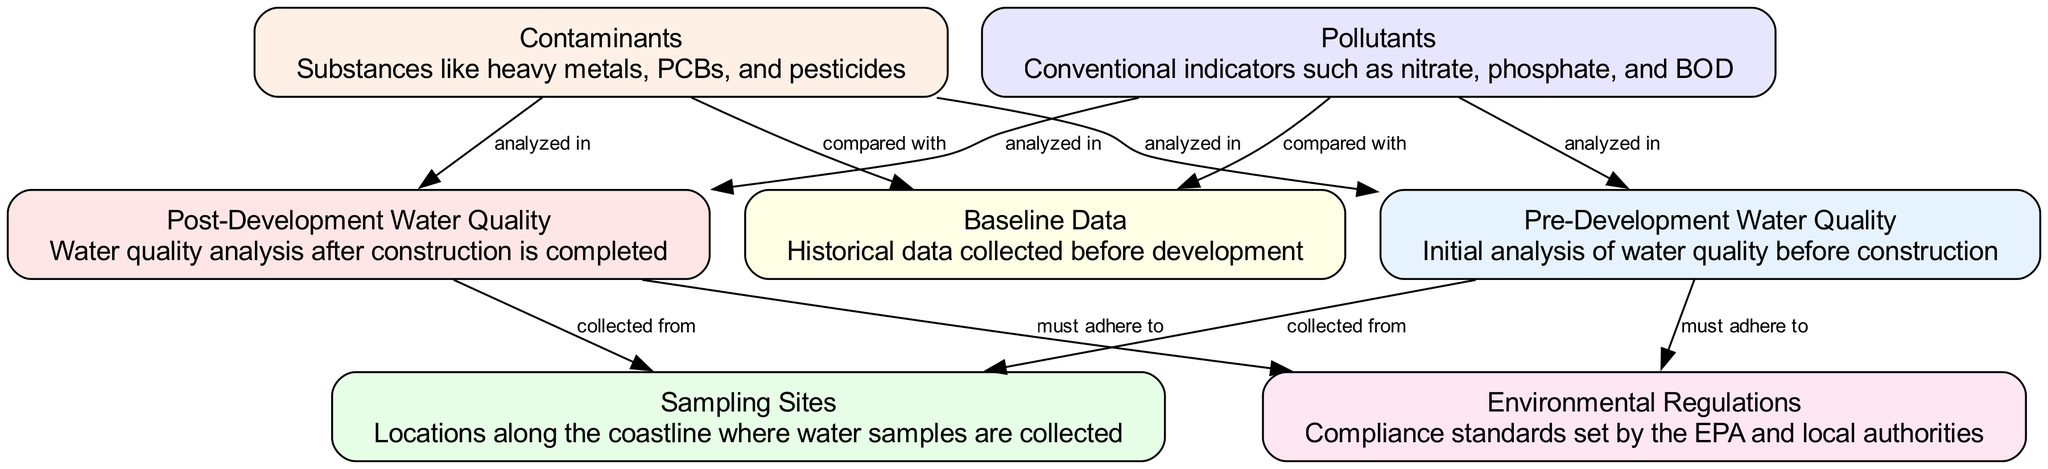What is the first node in the diagram? The first node listed is "Pre-Development Water Quality," as it is the first element in the nodes list provided.
Answer: Pre-Development Water Quality How many sampling sites are indicated in the diagram? The diagram does not specify the number of sampling sites, but it includes a node labeled "Sampling Sites." Since the data does not specify a quantity, the answer cannot be determined from the diagram.
Answer: Not specified What is compared with contaminants in the diagram? The diagram explicitly states that contaminants are compared with baseline data, as indicated by the edge labeled "compared with".
Answer: Baseline Data Which environmental standards must both water analyses adhere to? Both the "Pre-Development Water Quality" and "Post-Development Water Quality" nodes indicate that they must adhere to "Environmental Regulations," so the connection confirms compliance requirements from this perspective.
Answer: Environmental Regulations What types of substances are classified as contaminants? The node labeled "Contaminants" describes them as heavy metals, PCBs, and pesticides, providing clarity on what is included in this category.
Answer: Heavy metals, PCBs, and pesticides What is the relationship between water quality pre-development and analysis? Water quality pre-development is analyzed in the context of both contaminants and pollutants, as shown by the edges connecting these nodes back to "Pre-Development Water Quality."
Answer: Analyzed in Which node represents the analysis done after construction? The node labeled "Post-Development Water Quality" represents the analysis done after the construction is completed, according to the diagram's structure.
Answer: Post-Development Water Quality What are the conventional indicators mentioned for pollutants? The diagram mentions conventional indicators such as nitrate, phosphate, and BOD under the node called "Pollutants."
Answer: Nitrate, phosphate, and BOD How are the pre and post-development analyses related to sampling sites? Both the analyses—pre and post-development—collect samples from the "Sampling Sites," establishing a direct relationship as indicated by the edges connecting the nodes.
Answer: Collected from Sampling Sites 